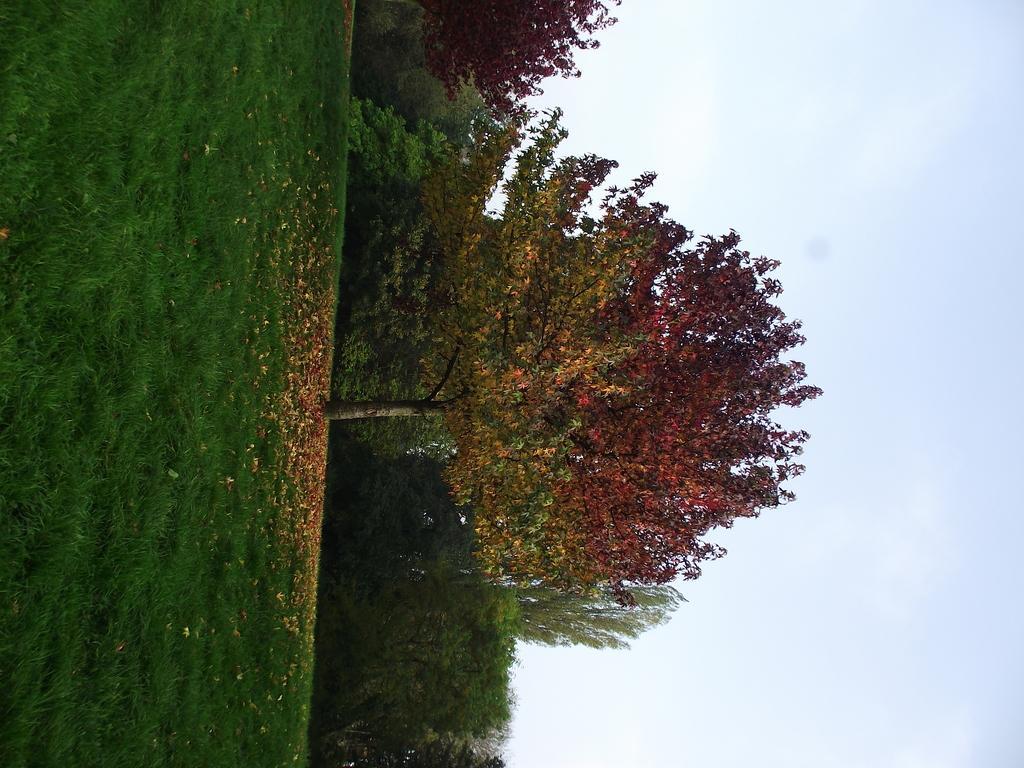How would you summarize this image in a sentence or two? In this image we can see some trees. Image also consists of grass and some dried leaves. Sky is also visible. 